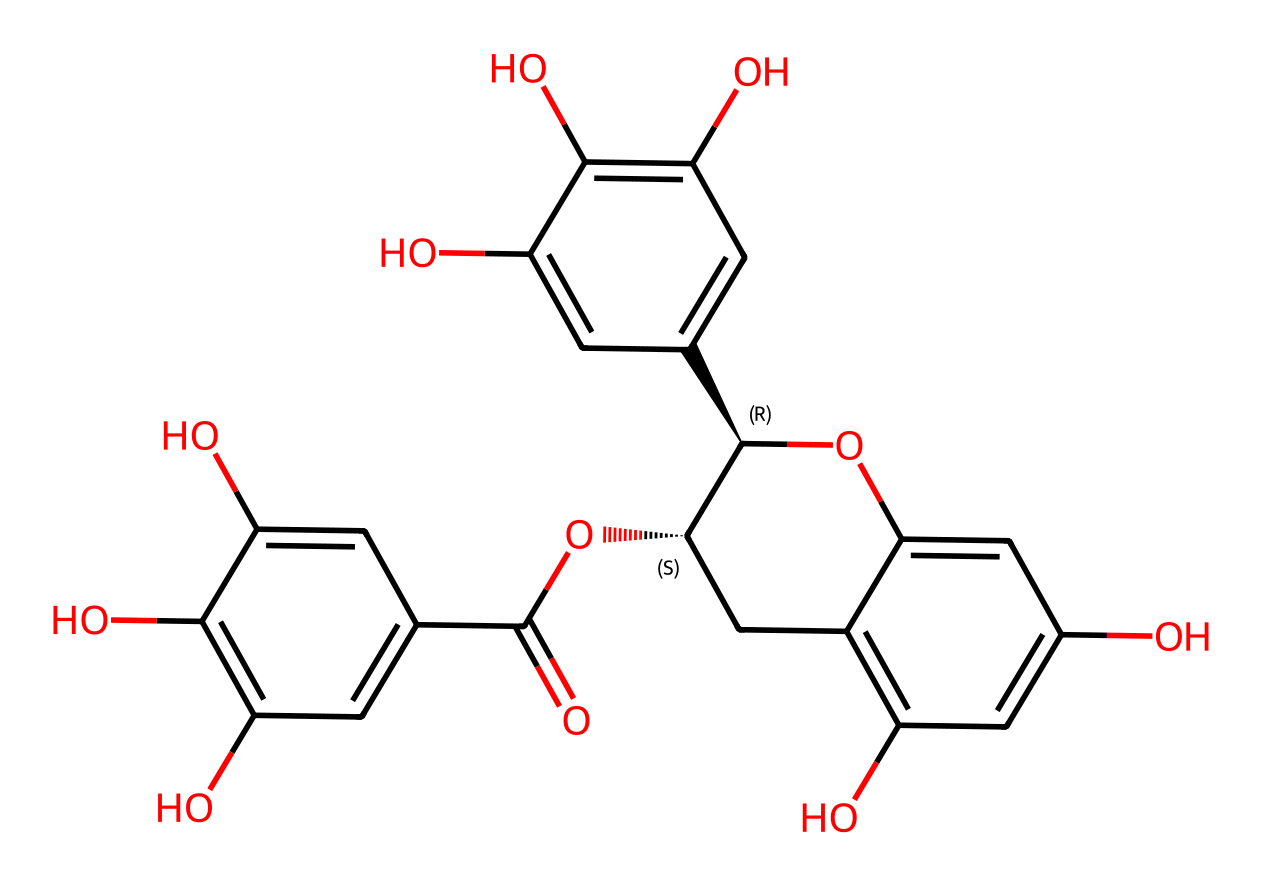What is the molecular formula of epigallocatechin gallate (EGCG)? The SMILES representation can be converted to reveal the molecular formula, which denotes the number of each type of atom: carbon (C), hydrogen (H), and oxygen (O). By counting from the structure, EGCG is found to have 22 carbons, 18 hydrogens, and 11 oxygens.
Answer: C22H18O11 How many hydroxyl groups (-OH) are present in this molecule? By examining the structure visually or through the SMILES, one can identify hydroxyl (-OH) groups attached to the aromatic rings. This specific structure contains 5 hydroxyl groups.
Answer: 5 Which component contributes to the antioxidant activity of EGCG? Antioxidant activity is generally associated with the presence of phenolic -OH groups, which donate hydrogen atoms to free radicals. In this molecule, the multiple hydroxyl groups are responsible for its antioxidant properties.
Answer: hydroxyl groups What functional groups can be identified in EGCG? Analyzing the structure for identifiable functional groups shows the presence of phenolic and carboxylic acid groups, which can be recognized by their corresponding structures in the molecule.
Answer: phenolic, carboxylic acid What is the significance of the stereochemistry in this molecule? The presence of stereocenters indicated by the chirality symbols (@) affects the three-dimensional shape of EGCG, which influences how it interacts with biological targets, enhancing its activity as an antioxidant.
Answer: stereochemistry impacts activity 